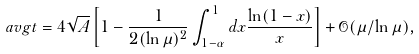<formula> <loc_0><loc_0><loc_500><loc_500>\ a v g { t } = 4 \sqrt { A } \left [ 1 - \frac { 1 } { 2 ( \ln \mu ) ^ { 2 } } \int _ { 1 - \alpha } ^ { 1 } d x \frac { \ln ( 1 - x ) } { x } \right ] + \mathcal { O } ( \mu / \ln \mu ) ,</formula> 